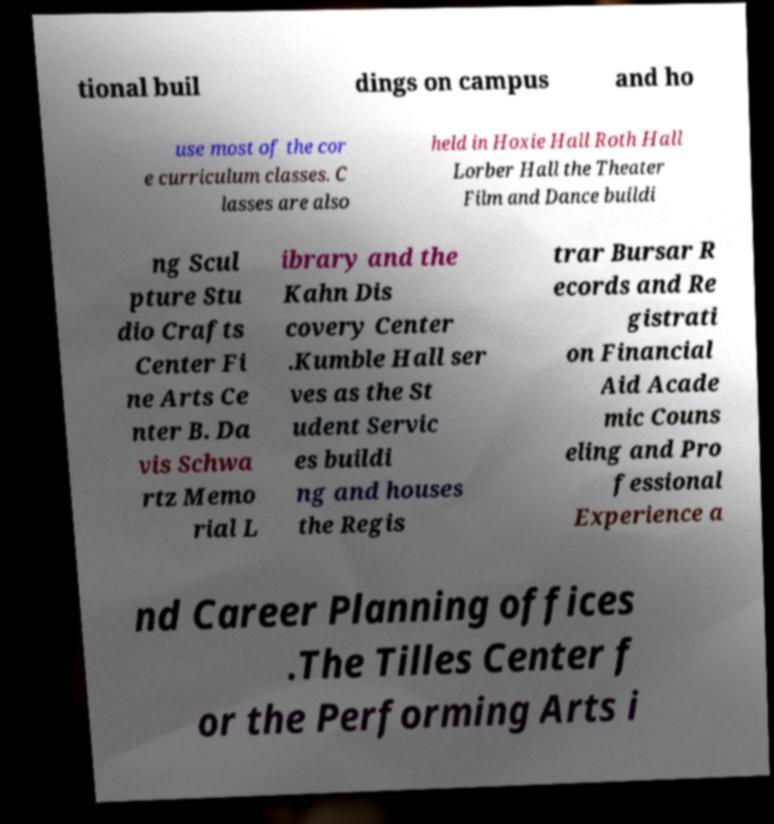For documentation purposes, I need the text within this image transcribed. Could you provide that? tional buil dings on campus and ho use most of the cor e curriculum classes. C lasses are also held in Hoxie Hall Roth Hall Lorber Hall the Theater Film and Dance buildi ng Scul pture Stu dio Crafts Center Fi ne Arts Ce nter B. Da vis Schwa rtz Memo rial L ibrary and the Kahn Dis covery Center .Kumble Hall ser ves as the St udent Servic es buildi ng and houses the Regis trar Bursar R ecords and Re gistrati on Financial Aid Acade mic Couns eling and Pro fessional Experience a nd Career Planning offices .The Tilles Center f or the Performing Arts i 